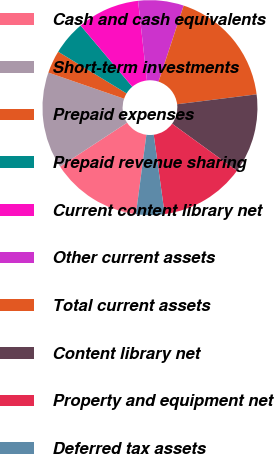Convert chart to OTSL. <chart><loc_0><loc_0><loc_500><loc_500><pie_chart><fcel>Cash and cash equivalents<fcel>Short-term investments<fcel>Prepaid expenses<fcel>Prepaid revenue sharing<fcel>Current content library net<fcel>Other current assets<fcel>Total current assets<fcel>Content library net<fcel>Property and equipment net<fcel>Deferred tax assets<nl><fcel>13.67%<fcel>14.53%<fcel>3.42%<fcel>5.13%<fcel>9.4%<fcel>6.84%<fcel>17.95%<fcel>11.97%<fcel>12.82%<fcel>4.27%<nl></chart> 